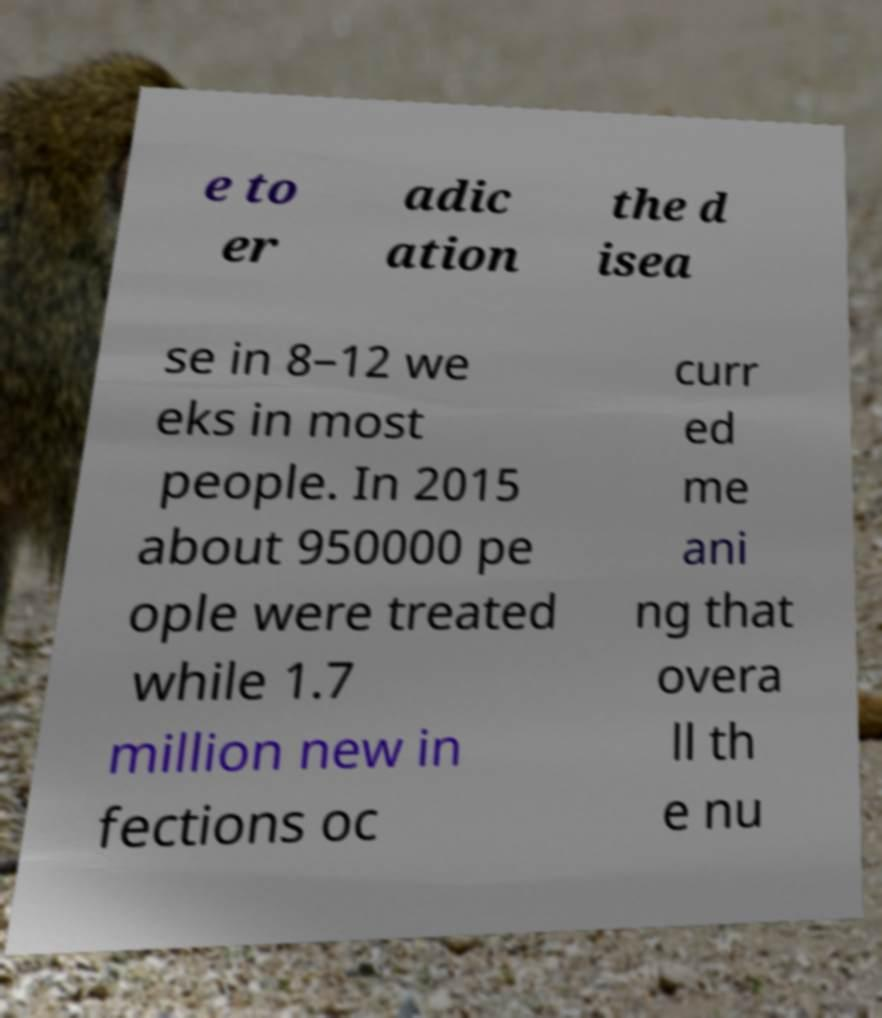I need the written content from this picture converted into text. Can you do that? e to er adic ation the d isea se in 8–12 we eks in most people. In 2015 about 950000 pe ople were treated while 1.7 million new in fections oc curr ed me ani ng that overa ll th e nu 